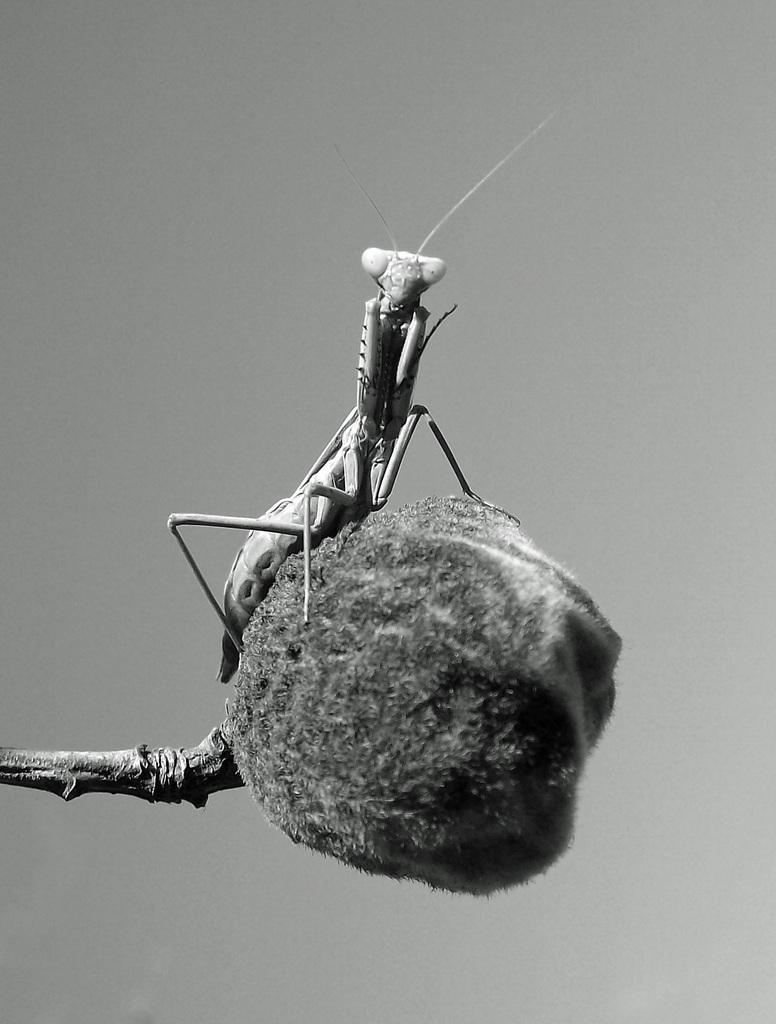What type of image is present in the picture? The image contains a black and white picture. What is the main subject of the picture? The picture depicts a grasshopper. Where is the grasshopper situated in the picture? The grasshopper is sitting on a branch. What type of discovery did the grasshopper make during its trip in the image? There is no indication in the image that the grasshopper made any discovery or went on a trip. 